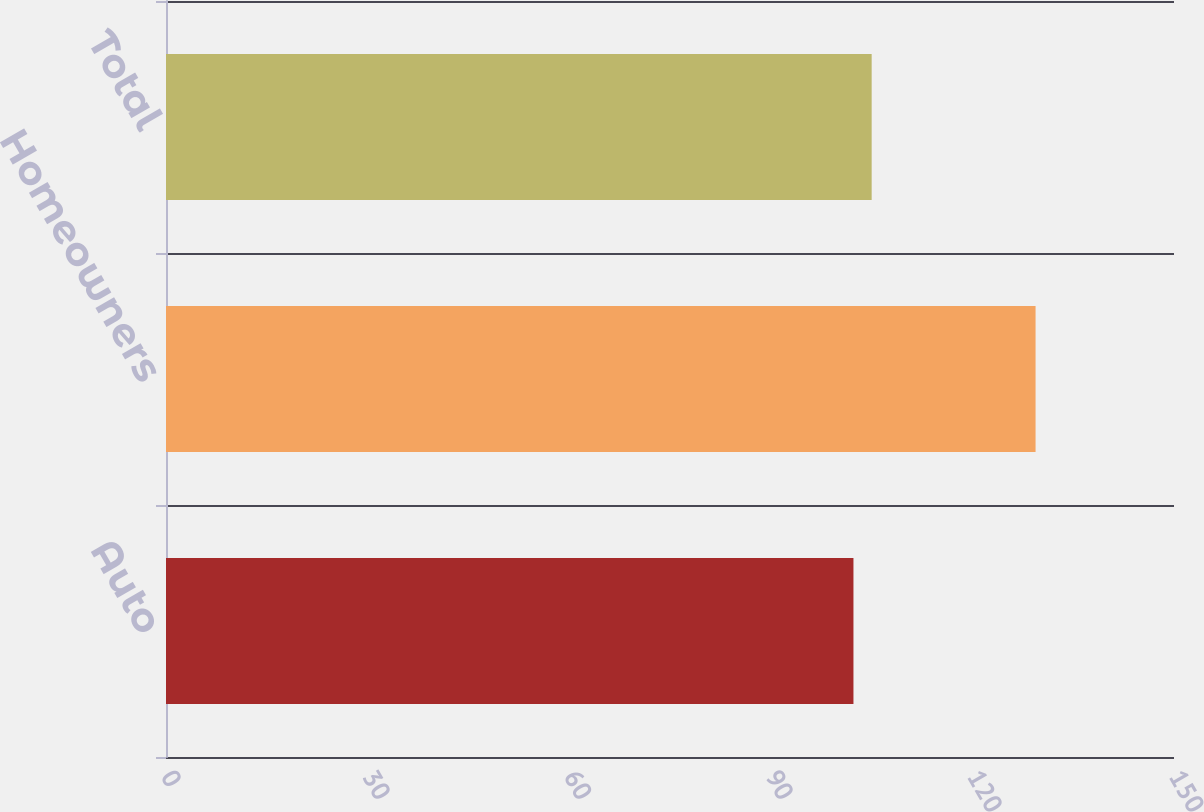Convert chart to OTSL. <chart><loc_0><loc_0><loc_500><loc_500><bar_chart><fcel>Auto<fcel>Homeowners<fcel>Total<nl><fcel>102.3<fcel>129.4<fcel>105.01<nl></chart> 